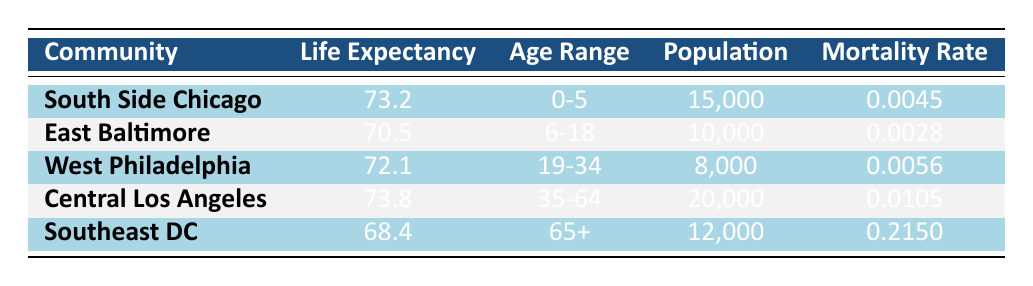What is the life expectancy in Southeast DC? The table shows that Southeast DC has a life expectancy value of 68.4 for the year 2020.
Answer: 68.4 Which community has the highest mortality rate? By comparing the mortality rates listed in the table, Southeast DC has the highest mortality rate at 0.2150.
Answer: Southeast DC What is the average life expectancy for all communities listed? Adding the life expectancies: 73.2 + 70.5 + 72.1 + 73.8 + 68.4 = 358.0. There are 5 communities, so the average is 358.0 / 5 = 71.6.
Answer: 71.6 Is the life expectancy in West Philadelphia greater than that in East Baltimore? West Philadelphia has a life expectancy of 72.1, while East Baltimore has a life expectancy of 70.5. Since 72.1 is greater than 70.5, the statement is true.
Answer: Yes What is the total population across all communities? Summing the populations: 15000 + 10000 + 8000 + 20000 + 12000 = 65000.
Answer: 65000 What percentage of the total population does Southeast DC represent? The total population is 65000. Southeast DC's population is 12000. Calculating the percentage: (12000 / 65000) * 100 ≈ 18.46%.
Answer: 18.46% Which community has the lowest life expectancy, and what is that value? Looking at the life expectancy values, Southeast DC has the lowest value of 68.4.
Answer: Southeast DC, 68.4 How many more years does Central Los Angeles have in life expectancy compared to Southeast DC? Central Los Angeles has a life expectancy of 73.8, whereas Southeast DC has 68.4. The difference is 73.8 - 68.4 = 5.4 years.
Answer: 5.4 years Is it true that the population in South Side Chicago exceeds that in West Philadelphia? South Side Chicago has a population of 15000, while West Philadelphia has 8000. Since 15000 is greater than 8000, the statement is true.
Answer: Yes 